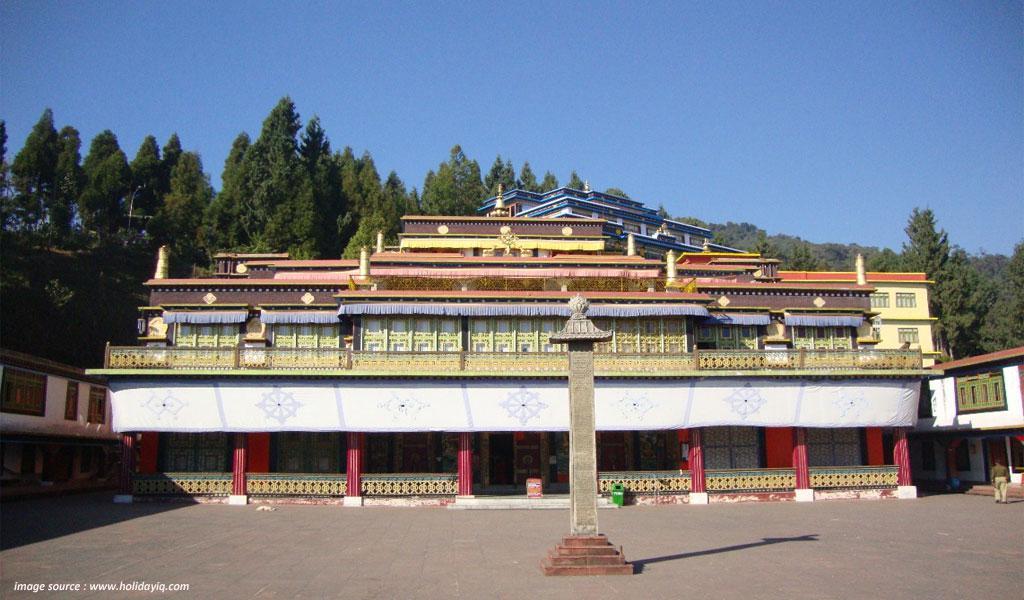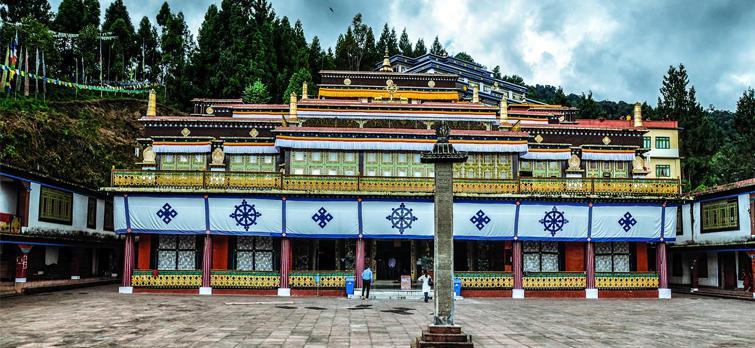The first image is the image on the left, the second image is the image on the right. Considering the images on both sides, is "An image shows the exterior of a temple with bold, decorative symbols repeating across a white banner running the length of the building." valid? Answer yes or no. Yes. The first image is the image on the left, the second image is the image on the right. Considering the images on both sides, is "The left and right image contains the same number of monasteries." valid? Answer yes or no. Yes. 